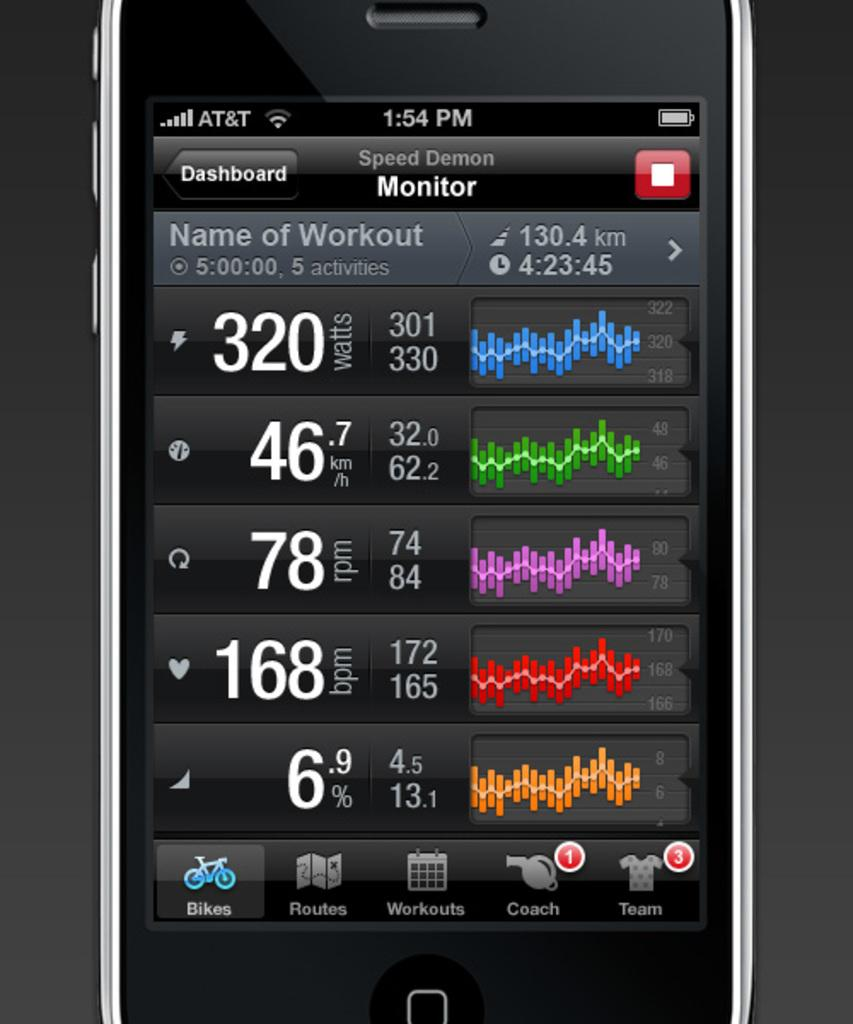<image>
Summarize the visual content of the image. A phone app monitor named Spped Demon showing the different graphs. 